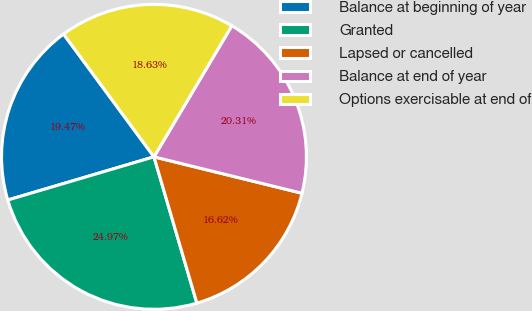Convert chart. <chart><loc_0><loc_0><loc_500><loc_500><pie_chart><fcel>Balance at beginning of year<fcel>Granted<fcel>Lapsed or cancelled<fcel>Balance at end of year<fcel>Options exercisable at end of<nl><fcel>19.47%<fcel>24.97%<fcel>16.62%<fcel>20.31%<fcel>18.63%<nl></chart> 